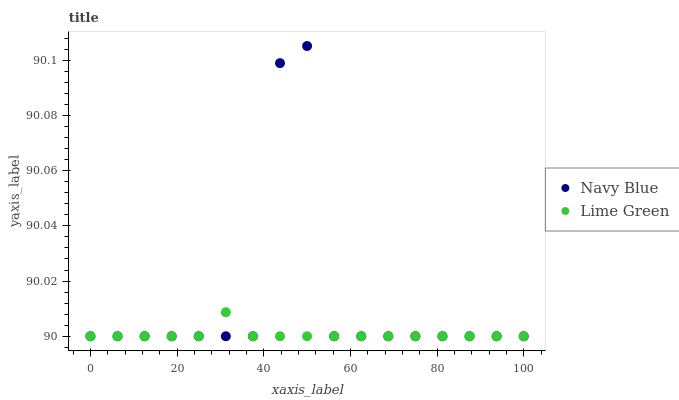Does Lime Green have the minimum area under the curve?
Answer yes or no. Yes. Does Navy Blue have the maximum area under the curve?
Answer yes or no. Yes. Does Lime Green have the maximum area under the curve?
Answer yes or no. No. Is Lime Green the smoothest?
Answer yes or no. Yes. Is Navy Blue the roughest?
Answer yes or no. Yes. Is Lime Green the roughest?
Answer yes or no. No. Does Navy Blue have the lowest value?
Answer yes or no. Yes. Does Navy Blue have the highest value?
Answer yes or no. Yes. Does Lime Green have the highest value?
Answer yes or no. No. Does Lime Green intersect Navy Blue?
Answer yes or no. Yes. Is Lime Green less than Navy Blue?
Answer yes or no. No. Is Lime Green greater than Navy Blue?
Answer yes or no. No. 